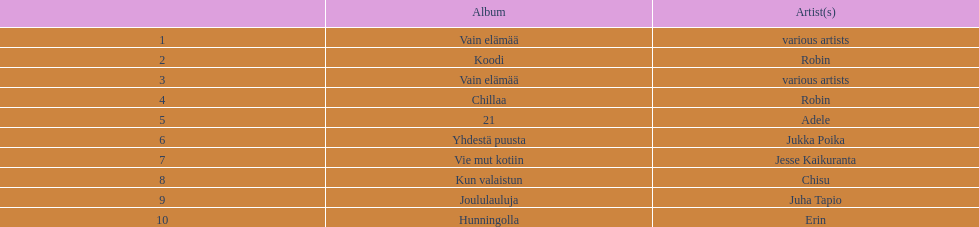Which album has the highest number of sales but doesn't have a designated artist? Vain elämää. 